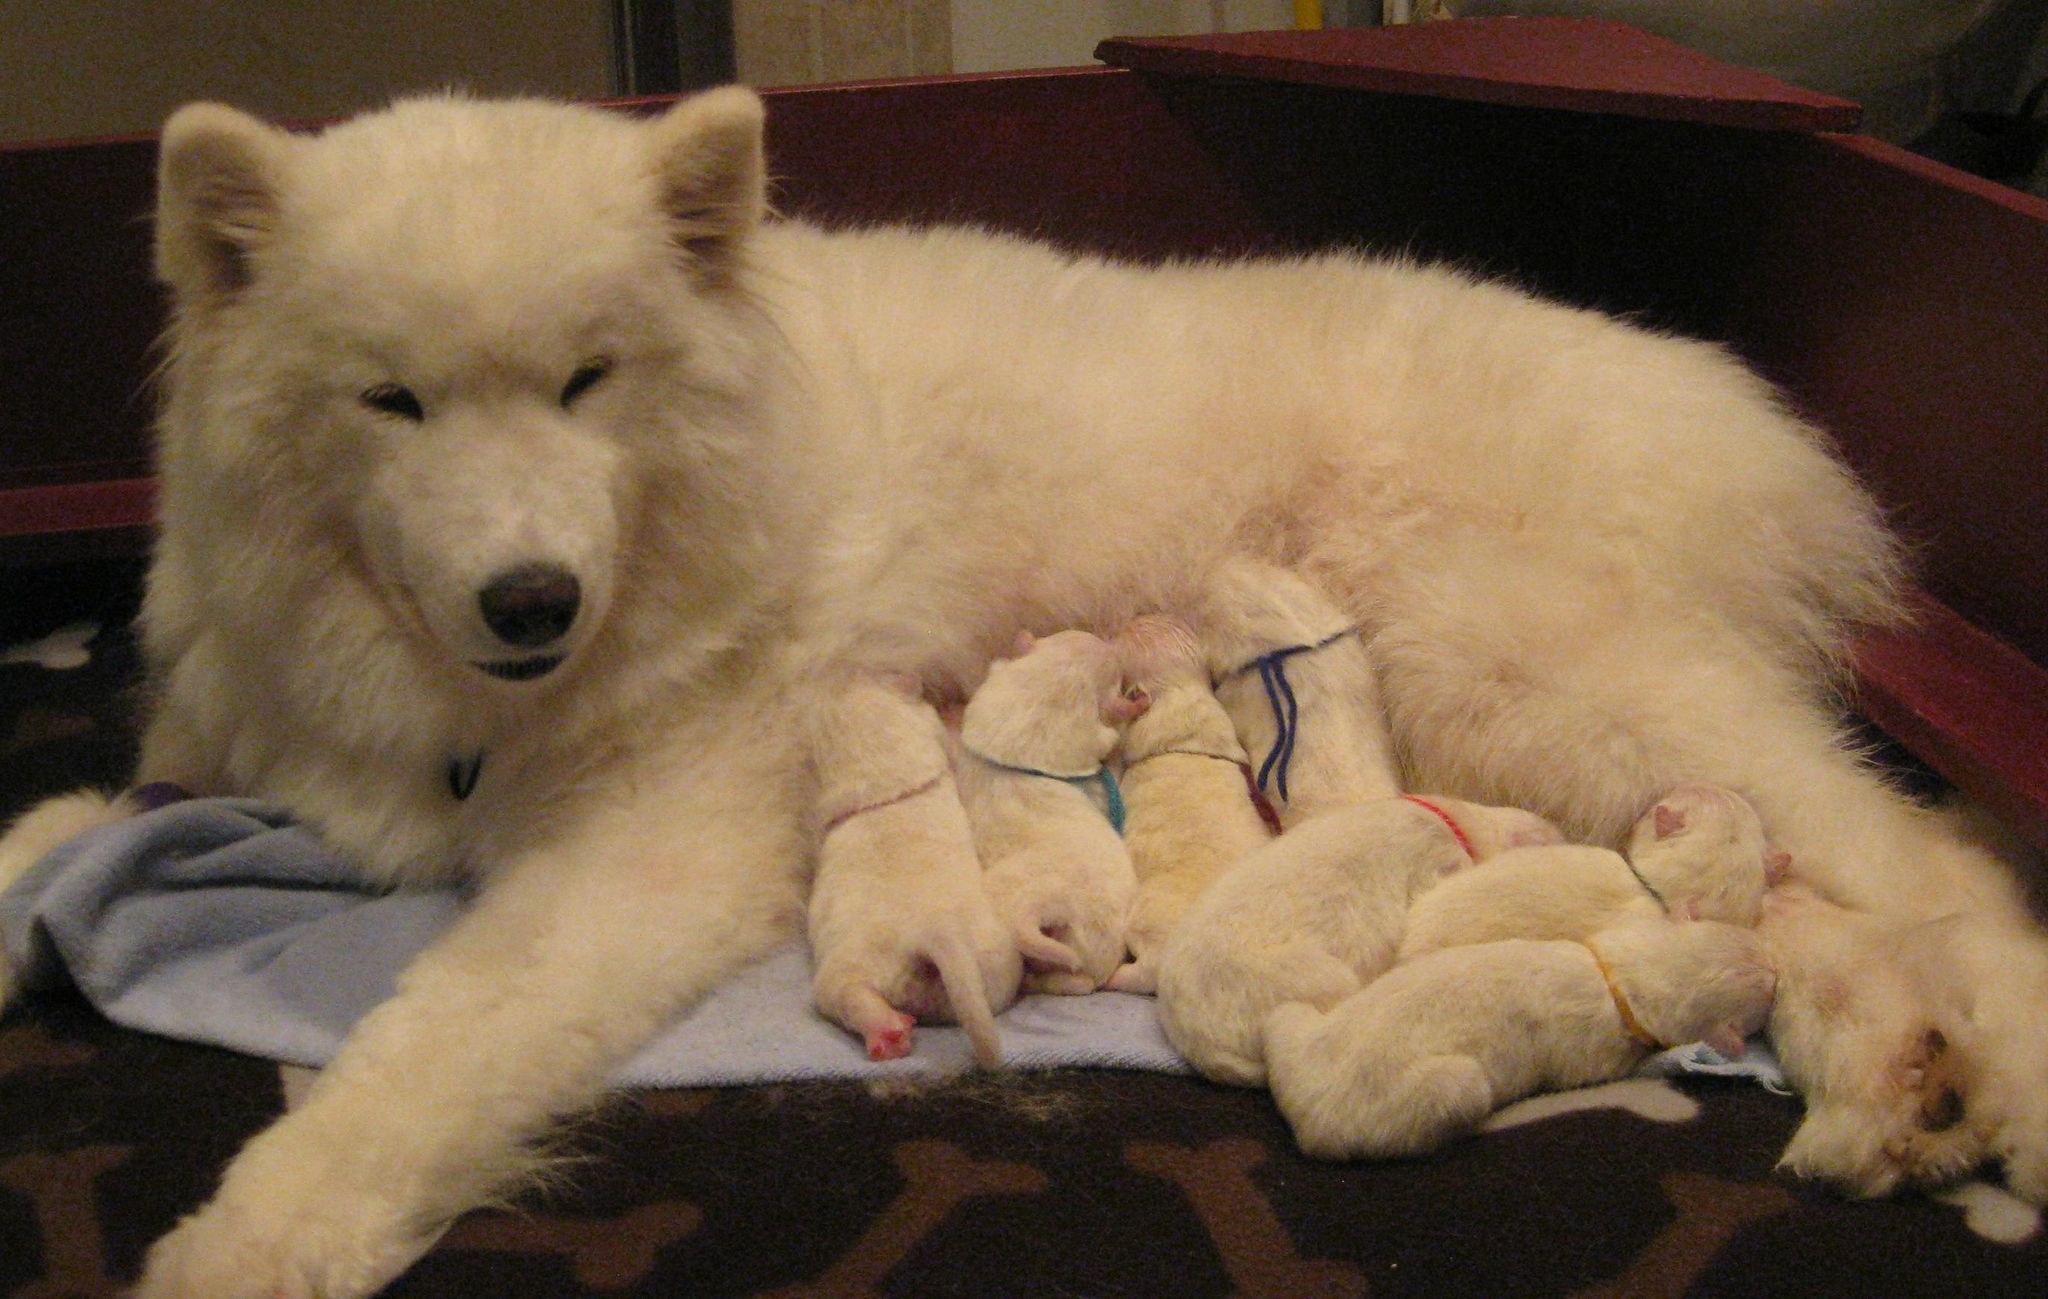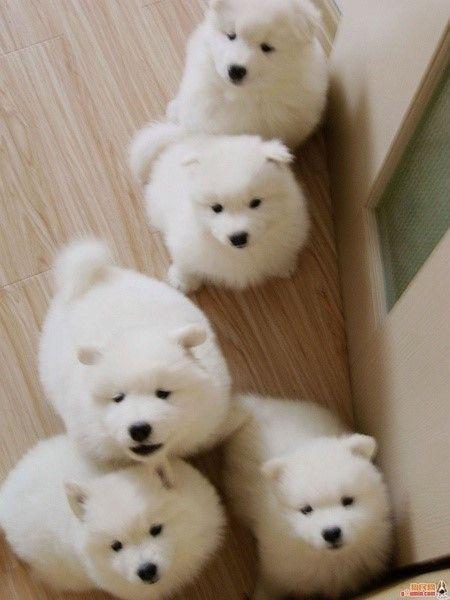The first image is the image on the left, the second image is the image on the right. Evaluate the accuracy of this statement regarding the images: "There are less than four dogs and none of them have their mouth open.". Is it true? Answer yes or no. No. 